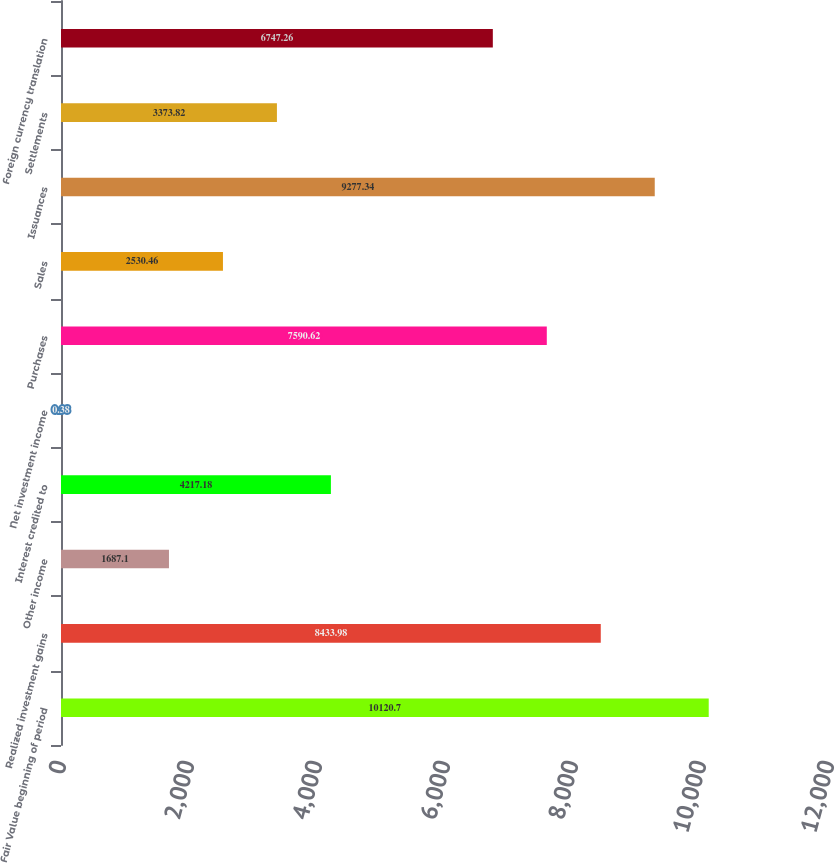Convert chart to OTSL. <chart><loc_0><loc_0><loc_500><loc_500><bar_chart><fcel>Fair Value beginning of period<fcel>Realized investment gains<fcel>Other income<fcel>Interest credited to<fcel>Net investment income<fcel>Purchases<fcel>Sales<fcel>Issuances<fcel>Settlements<fcel>Foreign currency translation<nl><fcel>10120.7<fcel>8433.98<fcel>1687.1<fcel>4217.18<fcel>0.38<fcel>7590.62<fcel>2530.46<fcel>9277.34<fcel>3373.82<fcel>6747.26<nl></chart> 